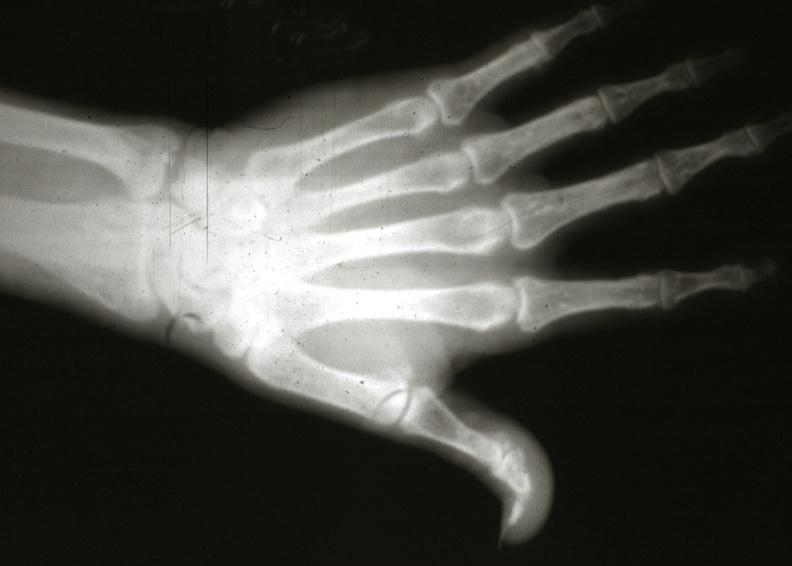what does this image show?
Answer the question using a single word or phrase. X-ray hand 